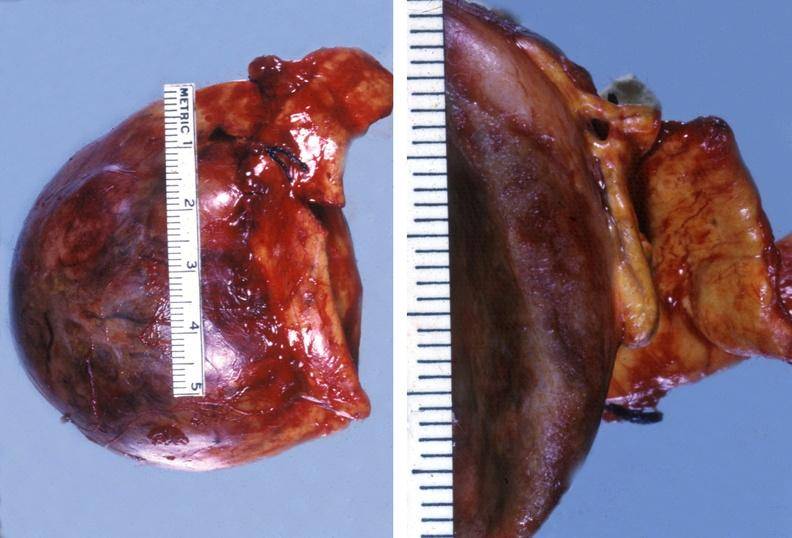s endocrine present?
Answer the question using a single word or phrase. Yes 